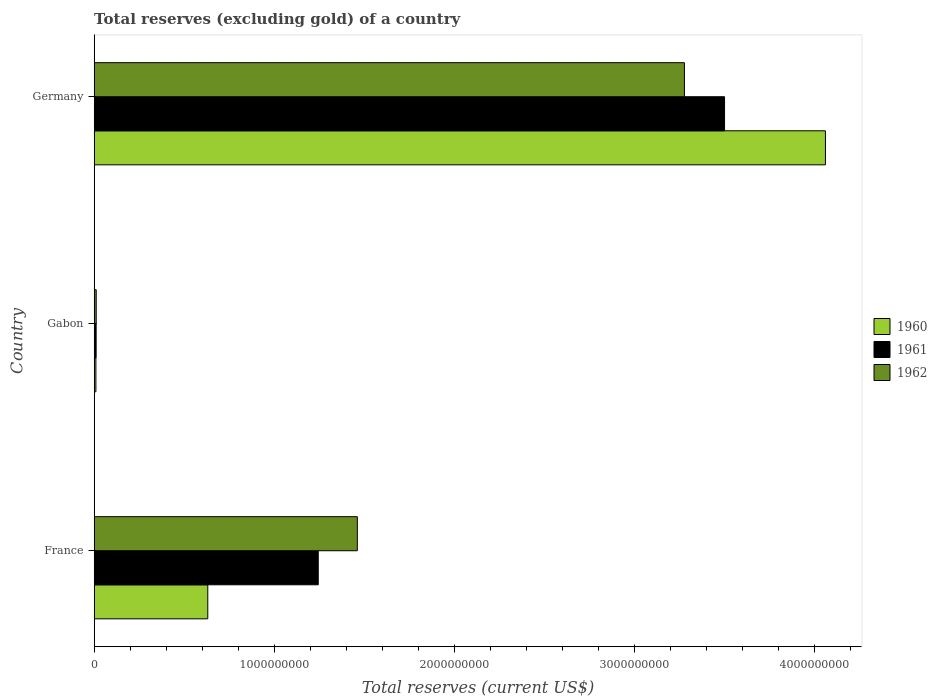How many different coloured bars are there?
Ensure brevity in your answer.  3. Are the number of bars per tick equal to the number of legend labels?
Give a very brief answer. Yes. Are the number of bars on each tick of the Y-axis equal?
Provide a succinct answer. Yes. How many bars are there on the 2nd tick from the top?
Provide a short and direct response. 3. What is the label of the 2nd group of bars from the top?
Provide a succinct answer. Gabon. In how many cases, is the number of bars for a given country not equal to the number of legend labels?
Make the answer very short. 0. What is the total reserves (excluding gold) in 1960 in France?
Ensure brevity in your answer.  6.31e+08. Across all countries, what is the maximum total reserves (excluding gold) in 1961?
Your answer should be compact. 3.50e+09. Across all countries, what is the minimum total reserves (excluding gold) in 1961?
Provide a succinct answer. 1.07e+07. In which country was the total reserves (excluding gold) in 1960 maximum?
Offer a very short reply. Germany. In which country was the total reserves (excluding gold) in 1961 minimum?
Your answer should be compact. Gabon. What is the total total reserves (excluding gold) in 1962 in the graph?
Make the answer very short. 4.75e+09. What is the difference between the total reserves (excluding gold) in 1962 in Gabon and that in Germany?
Your answer should be very brief. -3.27e+09. What is the difference between the total reserves (excluding gold) in 1962 in Germany and the total reserves (excluding gold) in 1960 in France?
Keep it short and to the point. 2.65e+09. What is the average total reserves (excluding gold) in 1961 per country?
Make the answer very short. 1.59e+09. What is the difference between the total reserves (excluding gold) in 1961 and total reserves (excluding gold) in 1960 in Gabon?
Ensure brevity in your answer.  1.20e+06. What is the ratio of the total reserves (excluding gold) in 1961 in Gabon to that in Germany?
Provide a short and direct response. 0. Is the total reserves (excluding gold) in 1962 in France less than that in Germany?
Offer a very short reply. Yes. Is the difference between the total reserves (excluding gold) in 1961 in France and Gabon greater than the difference between the total reserves (excluding gold) in 1960 in France and Gabon?
Keep it short and to the point. Yes. What is the difference between the highest and the second highest total reserves (excluding gold) in 1960?
Ensure brevity in your answer.  3.43e+09. What is the difference between the highest and the lowest total reserves (excluding gold) in 1962?
Ensure brevity in your answer.  3.27e+09. In how many countries, is the total reserves (excluding gold) in 1962 greater than the average total reserves (excluding gold) in 1962 taken over all countries?
Offer a terse response. 1. What does the 2nd bar from the bottom in Gabon represents?
Keep it short and to the point. 1961. Is it the case that in every country, the sum of the total reserves (excluding gold) in 1962 and total reserves (excluding gold) in 1961 is greater than the total reserves (excluding gold) in 1960?
Ensure brevity in your answer.  Yes. Are all the bars in the graph horizontal?
Your response must be concise. Yes. How many countries are there in the graph?
Keep it short and to the point. 3. Are the values on the major ticks of X-axis written in scientific E-notation?
Provide a succinct answer. No. Where does the legend appear in the graph?
Offer a very short reply. Center right. How are the legend labels stacked?
Offer a very short reply. Vertical. What is the title of the graph?
Offer a terse response. Total reserves (excluding gold) of a country. What is the label or title of the X-axis?
Provide a succinct answer. Total reserves (current US$). What is the label or title of the Y-axis?
Offer a very short reply. Country. What is the Total reserves (current US$) of 1960 in France?
Provide a succinct answer. 6.31e+08. What is the Total reserves (current US$) in 1961 in France?
Make the answer very short. 1.24e+09. What is the Total reserves (current US$) of 1962 in France?
Give a very brief answer. 1.46e+09. What is the Total reserves (current US$) of 1960 in Gabon?
Your response must be concise. 9.50e+06. What is the Total reserves (current US$) of 1961 in Gabon?
Make the answer very short. 1.07e+07. What is the Total reserves (current US$) of 1962 in Gabon?
Provide a succinct answer. 1.12e+07. What is the Total reserves (current US$) of 1960 in Germany?
Ensure brevity in your answer.  4.06e+09. What is the Total reserves (current US$) of 1961 in Germany?
Your response must be concise. 3.50e+09. What is the Total reserves (current US$) in 1962 in Germany?
Make the answer very short. 3.28e+09. Across all countries, what is the maximum Total reserves (current US$) of 1960?
Your answer should be very brief. 4.06e+09. Across all countries, what is the maximum Total reserves (current US$) in 1961?
Offer a very short reply. 3.50e+09. Across all countries, what is the maximum Total reserves (current US$) of 1962?
Offer a very short reply. 3.28e+09. Across all countries, what is the minimum Total reserves (current US$) of 1960?
Keep it short and to the point. 9.50e+06. Across all countries, what is the minimum Total reserves (current US$) of 1961?
Your answer should be very brief. 1.07e+07. Across all countries, what is the minimum Total reserves (current US$) in 1962?
Your response must be concise. 1.12e+07. What is the total Total reserves (current US$) of 1960 in the graph?
Your answer should be compact. 4.70e+09. What is the total Total reserves (current US$) in 1961 in the graph?
Make the answer very short. 4.76e+09. What is the total Total reserves (current US$) in 1962 in the graph?
Ensure brevity in your answer.  4.75e+09. What is the difference between the Total reserves (current US$) in 1960 in France and that in Gabon?
Keep it short and to the point. 6.21e+08. What is the difference between the Total reserves (current US$) of 1961 in France and that in Gabon?
Keep it short and to the point. 1.23e+09. What is the difference between the Total reserves (current US$) of 1962 in France and that in Gabon?
Ensure brevity in your answer.  1.45e+09. What is the difference between the Total reserves (current US$) in 1960 in France and that in Germany?
Your answer should be compact. -3.43e+09. What is the difference between the Total reserves (current US$) in 1961 in France and that in Germany?
Keep it short and to the point. -2.26e+09. What is the difference between the Total reserves (current US$) in 1962 in France and that in Germany?
Provide a succinct answer. -1.82e+09. What is the difference between the Total reserves (current US$) in 1960 in Gabon and that in Germany?
Make the answer very short. -4.05e+09. What is the difference between the Total reserves (current US$) in 1961 in Gabon and that in Germany?
Ensure brevity in your answer.  -3.49e+09. What is the difference between the Total reserves (current US$) in 1962 in Gabon and that in Germany?
Offer a terse response. -3.27e+09. What is the difference between the Total reserves (current US$) of 1960 in France and the Total reserves (current US$) of 1961 in Gabon?
Give a very brief answer. 6.20e+08. What is the difference between the Total reserves (current US$) of 1960 in France and the Total reserves (current US$) of 1962 in Gabon?
Your response must be concise. 6.20e+08. What is the difference between the Total reserves (current US$) of 1961 in France and the Total reserves (current US$) of 1962 in Gabon?
Your answer should be very brief. 1.23e+09. What is the difference between the Total reserves (current US$) of 1960 in France and the Total reserves (current US$) of 1961 in Germany?
Provide a succinct answer. -2.87e+09. What is the difference between the Total reserves (current US$) of 1960 in France and the Total reserves (current US$) of 1962 in Germany?
Your response must be concise. -2.65e+09. What is the difference between the Total reserves (current US$) in 1961 in France and the Total reserves (current US$) in 1962 in Germany?
Offer a very short reply. -2.03e+09. What is the difference between the Total reserves (current US$) of 1960 in Gabon and the Total reserves (current US$) of 1961 in Germany?
Offer a very short reply. -3.49e+09. What is the difference between the Total reserves (current US$) of 1960 in Gabon and the Total reserves (current US$) of 1962 in Germany?
Your answer should be compact. -3.27e+09. What is the difference between the Total reserves (current US$) in 1961 in Gabon and the Total reserves (current US$) in 1962 in Germany?
Provide a short and direct response. -3.27e+09. What is the average Total reserves (current US$) in 1960 per country?
Make the answer very short. 1.57e+09. What is the average Total reserves (current US$) of 1961 per country?
Ensure brevity in your answer.  1.59e+09. What is the average Total reserves (current US$) of 1962 per country?
Ensure brevity in your answer.  1.58e+09. What is the difference between the Total reserves (current US$) of 1960 and Total reserves (current US$) of 1961 in France?
Make the answer very short. -6.14e+08. What is the difference between the Total reserves (current US$) in 1960 and Total reserves (current US$) in 1962 in France?
Your answer should be very brief. -8.31e+08. What is the difference between the Total reserves (current US$) of 1961 and Total reserves (current US$) of 1962 in France?
Keep it short and to the point. -2.17e+08. What is the difference between the Total reserves (current US$) in 1960 and Total reserves (current US$) in 1961 in Gabon?
Provide a short and direct response. -1.20e+06. What is the difference between the Total reserves (current US$) in 1960 and Total reserves (current US$) in 1962 in Gabon?
Your answer should be compact. -1.75e+06. What is the difference between the Total reserves (current US$) in 1961 and Total reserves (current US$) in 1962 in Gabon?
Provide a succinct answer. -5.50e+05. What is the difference between the Total reserves (current US$) of 1960 and Total reserves (current US$) of 1961 in Germany?
Your response must be concise. 5.60e+08. What is the difference between the Total reserves (current US$) of 1960 and Total reserves (current US$) of 1962 in Germany?
Your response must be concise. 7.83e+08. What is the difference between the Total reserves (current US$) of 1961 and Total reserves (current US$) of 1962 in Germany?
Provide a short and direct response. 2.23e+08. What is the ratio of the Total reserves (current US$) in 1960 in France to that in Gabon?
Provide a short and direct response. 66.41. What is the ratio of the Total reserves (current US$) of 1961 in France to that in Gabon?
Provide a short and direct response. 116.3. What is the ratio of the Total reserves (current US$) in 1962 in France to that in Gabon?
Provide a short and direct response. 129.91. What is the ratio of the Total reserves (current US$) of 1960 in France to that in Germany?
Offer a very short reply. 0.16. What is the ratio of the Total reserves (current US$) in 1961 in France to that in Germany?
Your answer should be very brief. 0.36. What is the ratio of the Total reserves (current US$) of 1962 in France to that in Germany?
Offer a very short reply. 0.45. What is the ratio of the Total reserves (current US$) in 1960 in Gabon to that in Germany?
Give a very brief answer. 0. What is the ratio of the Total reserves (current US$) in 1961 in Gabon to that in Germany?
Your answer should be compact. 0. What is the ratio of the Total reserves (current US$) of 1962 in Gabon to that in Germany?
Your answer should be very brief. 0. What is the difference between the highest and the second highest Total reserves (current US$) in 1960?
Give a very brief answer. 3.43e+09. What is the difference between the highest and the second highest Total reserves (current US$) in 1961?
Keep it short and to the point. 2.26e+09. What is the difference between the highest and the second highest Total reserves (current US$) of 1962?
Offer a very short reply. 1.82e+09. What is the difference between the highest and the lowest Total reserves (current US$) of 1960?
Provide a short and direct response. 4.05e+09. What is the difference between the highest and the lowest Total reserves (current US$) of 1961?
Make the answer very short. 3.49e+09. What is the difference between the highest and the lowest Total reserves (current US$) of 1962?
Give a very brief answer. 3.27e+09. 